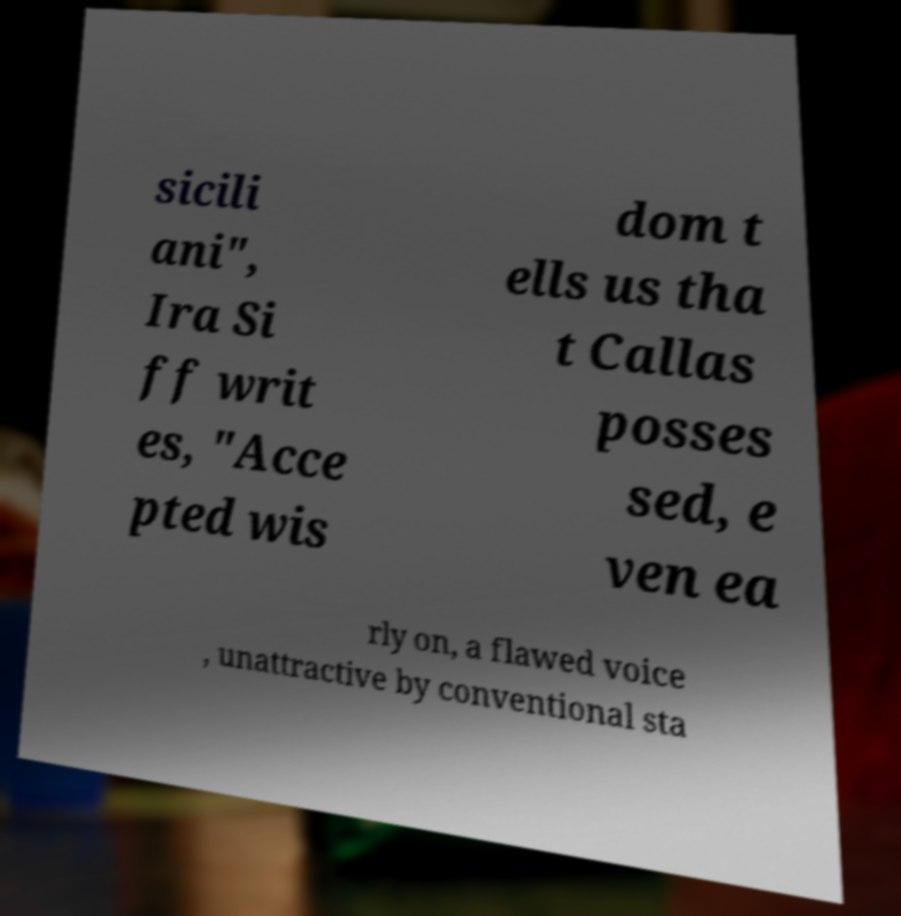Please identify and transcribe the text found in this image. sicili ani", Ira Si ff writ es, "Acce pted wis dom t ells us tha t Callas posses sed, e ven ea rly on, a flawed voice , unattractive by conventional sta 